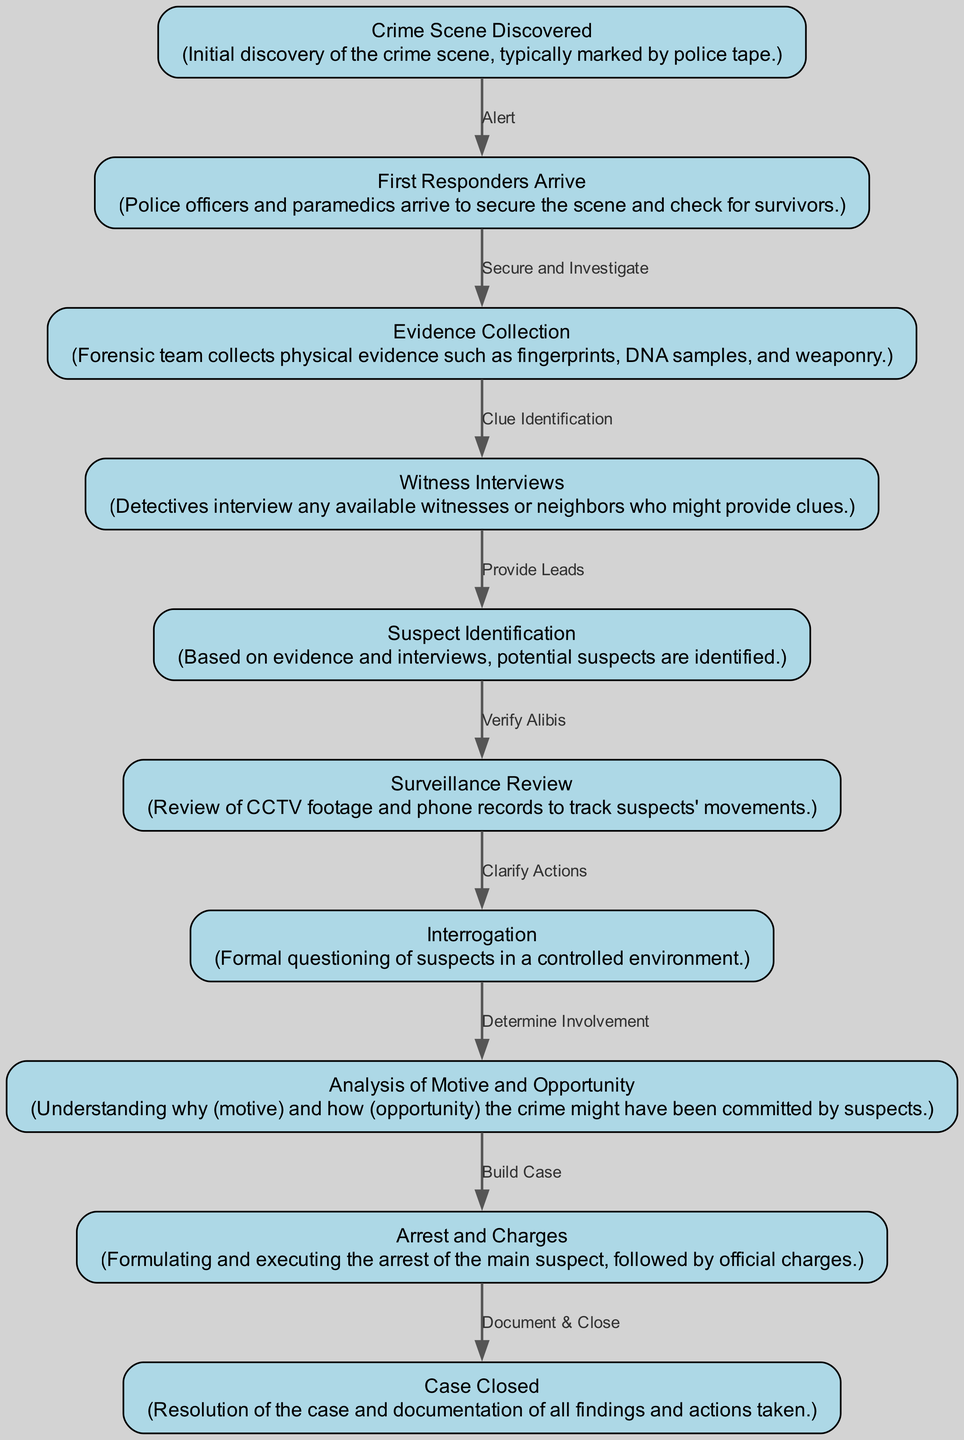What is the first step in the crime investigation procedure? The diagram lists "Crime Scene Discovered" as the starting point, indicating it is the initial step before any other actions are taken.
Answer: Crime Scene Discovered How many nodes are present in the diagram? By counting the entries under 'nodes', there are a total of ten distinct nodes outlining the different steps in the investigation.
Answer: 10 What follows after "Witness Interviews"? According to the flowchart, after "Witness Interviews," the next progression is to "Suspect Identification," which signifies that the interview stage leads to identifying potential suspects.
Answer: Suspect Identification What is the purpose of "Surveillance Review"? The diagram states that this step's purpose is to review CCTV footage and phone records to track suspects' movements, providing clarity on suspect activities.
Answer: Track suspects' movements If a suspect is arrested, what is the next step according to the flowchart? The flowchart indicates that once the "Arrest and Charges" step is executed, the ultimate action is "Case Closed," signifying that the investigation wraps up post-arrest.
Answer: Case Closed Which node represents the process of gathering physical evidence? The "Evidence Collection" node explicitly indicates that it entails the forensic team's gathering of physical evidence such as fingerprints and DNA samples.
Answer: Evidence Collection What is the relationship between "Interrogation" and "Analysis of Motive and Opportunity"? The diagram specifies that "Interrogation" leads to "Analysis of Motive and Opportunity," suggesting that interrogating suspects is crucial for understanding their potential involvement in the crime.
Answer: Determine Involvement Which nodes are connected by the edge labeled "Document & Close"? According to the edges shown in the flowchart, "Arrest and Charges" connects to "Case Closed" through the edge labeled "Document & Close," indicating this step is part of the conclusion process.
Answer: Arrest and Charges, Case Closed How do the "First Responders Arrive" contribute to the investigation? The diagram illustrates that the arrival of "First Responders" is pivotal as it follows the discovery of the crime scene, highlighting their role in securing the area and beginning the investigation.
Answer: Secure the scene What type of questioning is involved in the "Interrogation" node? The flowchart clearly states that "Interrogation" involves formal questioning, distinguishing it from other informal dialogue stages that might occur earlier in the investigation process.
Answer: Formal questioning 